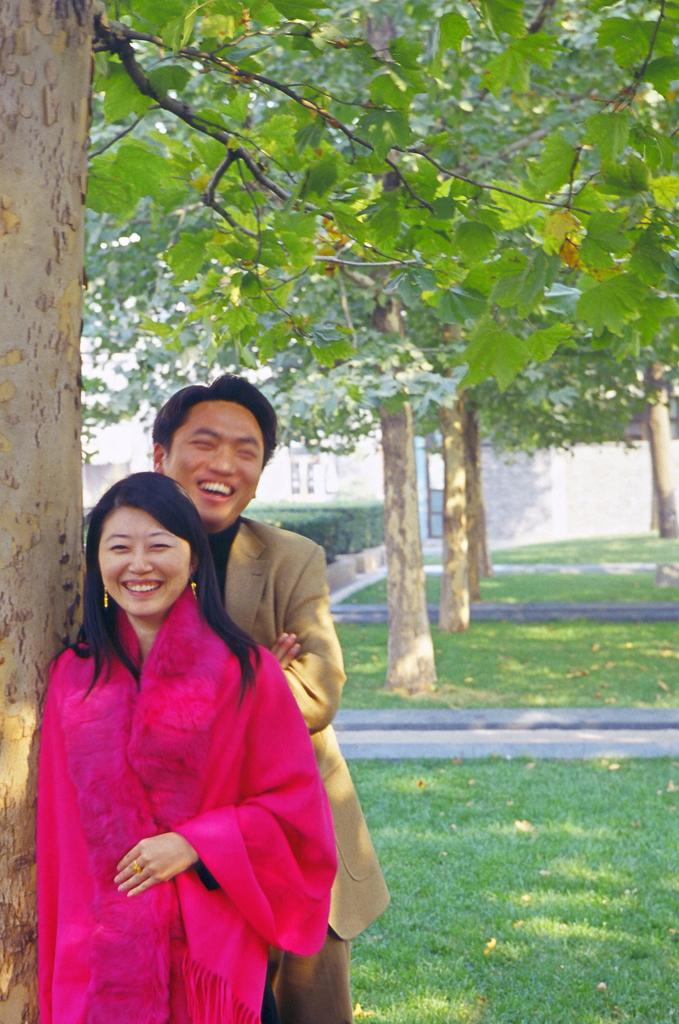How many people are in the image? There are two persons standing in the image. What is the facial expression of the people in the image? The persons are smiling. What can be seen in the background of the image? There are trees and a building visible in the background of the image. What is at the bottom of the image? There is grass and plants at the bottom of the image. What type of spoon is being used to blow the leaves in the image? There is no spoon or leaves present in the image. 